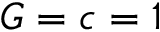<formula> <loc_0><loc_0><loc_500><loc_500>G = c = 1</formula> 